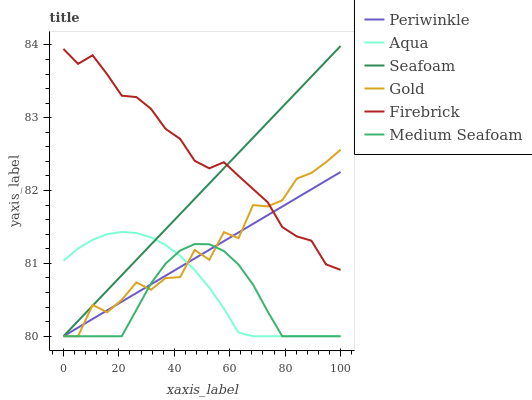Does Medium Seafoam have the minimum area under the curve?
Answer yes or no. Yes. Does Firebrick have the maximum area under the curve?
Answer yes or no. Yes. Does Aqua have the minimum area under the curve?
Answer yes or no. No. Does Aqua have the maximum area under the curve?
Answer yes or no. No. Is Periwinkle the smoothest?
Answer yes or no. Yes. Is Gold the roughest?
Answer yes or no. Yes. Is Firebrick the smoothest?
Answer yes or no. No. Is Firebrick the roughest?
Answer yes or no. No. Does Gold have the lowest value?
Answer yes or no. Yes. Does Firebrick have the lowest value?
Answer yes or no. No. Does Seafoam have the highest value?
Answer yes or no. Yes. Does Firebrick have the highest value?
Answer yes or no. No. Is Medium Seafoam less than Firebrick?
Answer yes or no. Yes. Is Firebrick greater than Aqua?
Answer yes or no. Yes. Does Periwinkle intersect Gold?
Answer yes or no. Yes. Is Periwinkle less than Gold?
Answer yes or no. No. Is Periwinkle greater than Gold?
Answer yes or no. No. Does Medium Seafoam intersect Firebrick?
Answer yes or no. No. 